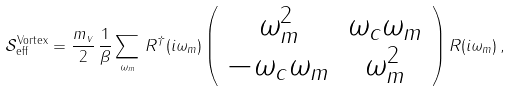Convert formula to latex. <formula><loc_0><loc_0><loc_500><loc_500>\mathcal { S } _ { \text {eff} } ^ { \text {Vortex} } = \frac { m _ { v } } { 2 } \, \frac { 1 } { \beta } \sum _ { \omega _ { m } } \, { R } ^ { \dagger } ( i \omega _ { m } ) \left ( \begin{array} { c c } \omega _ { m } ^ { 2 } & \omega _ { c } \omega _ { m } \\ - \omega _ { c } \omega _ { m } & \omega _ { m } ^ { 2 } \end{array} \right ) { R } ( i \omega _ { m } ) \, ,</formula> 